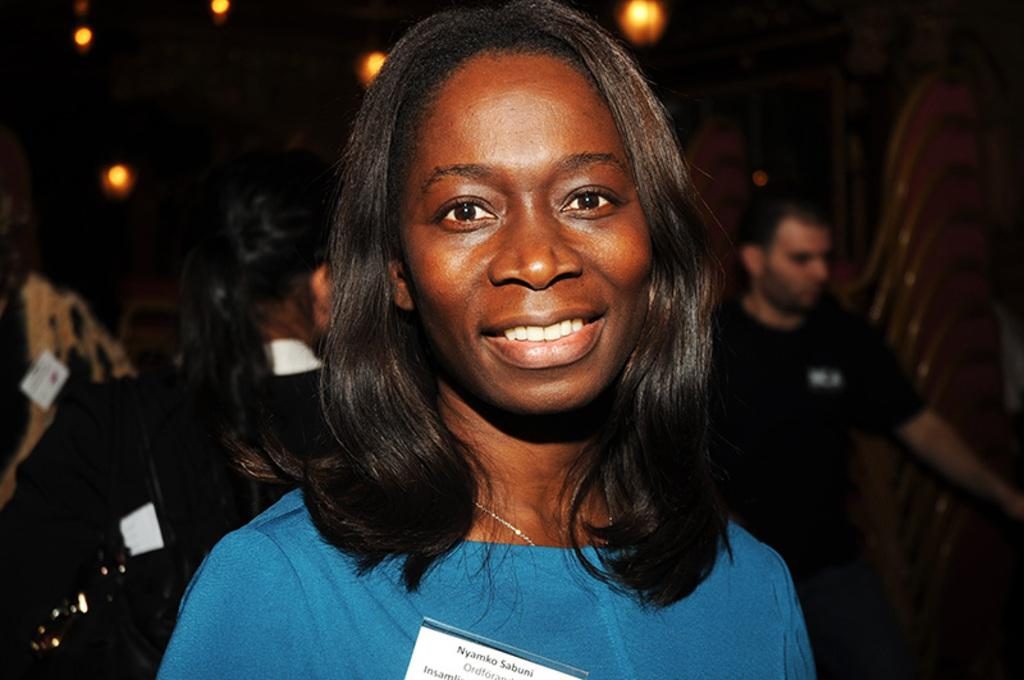Who is the main subject in the image? There is a lady in the image. What is the lady wearing? The lady is wearing a blue dress. Can you describe the people behind the lady? There are other people behind the lady, but their appearance is not specified in the facts. What is on the roof in the image? There are lights on the roof in the image. What type of feather can be seen on the lady's hat in the image? There is no mention of a hat or feather in the image, so it cannot be determined if there is a feather present. 